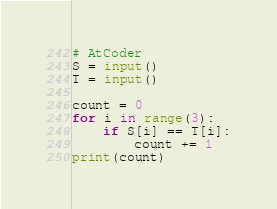Convert code to text. <code><loc_0><loc_0><loc_500><loc_500><_Python_># AtCoder
S = input()
T = input()

count = 0
for i in range(3):
    if S[i] == T[i]:
        count += 1
print(count)
</code> 